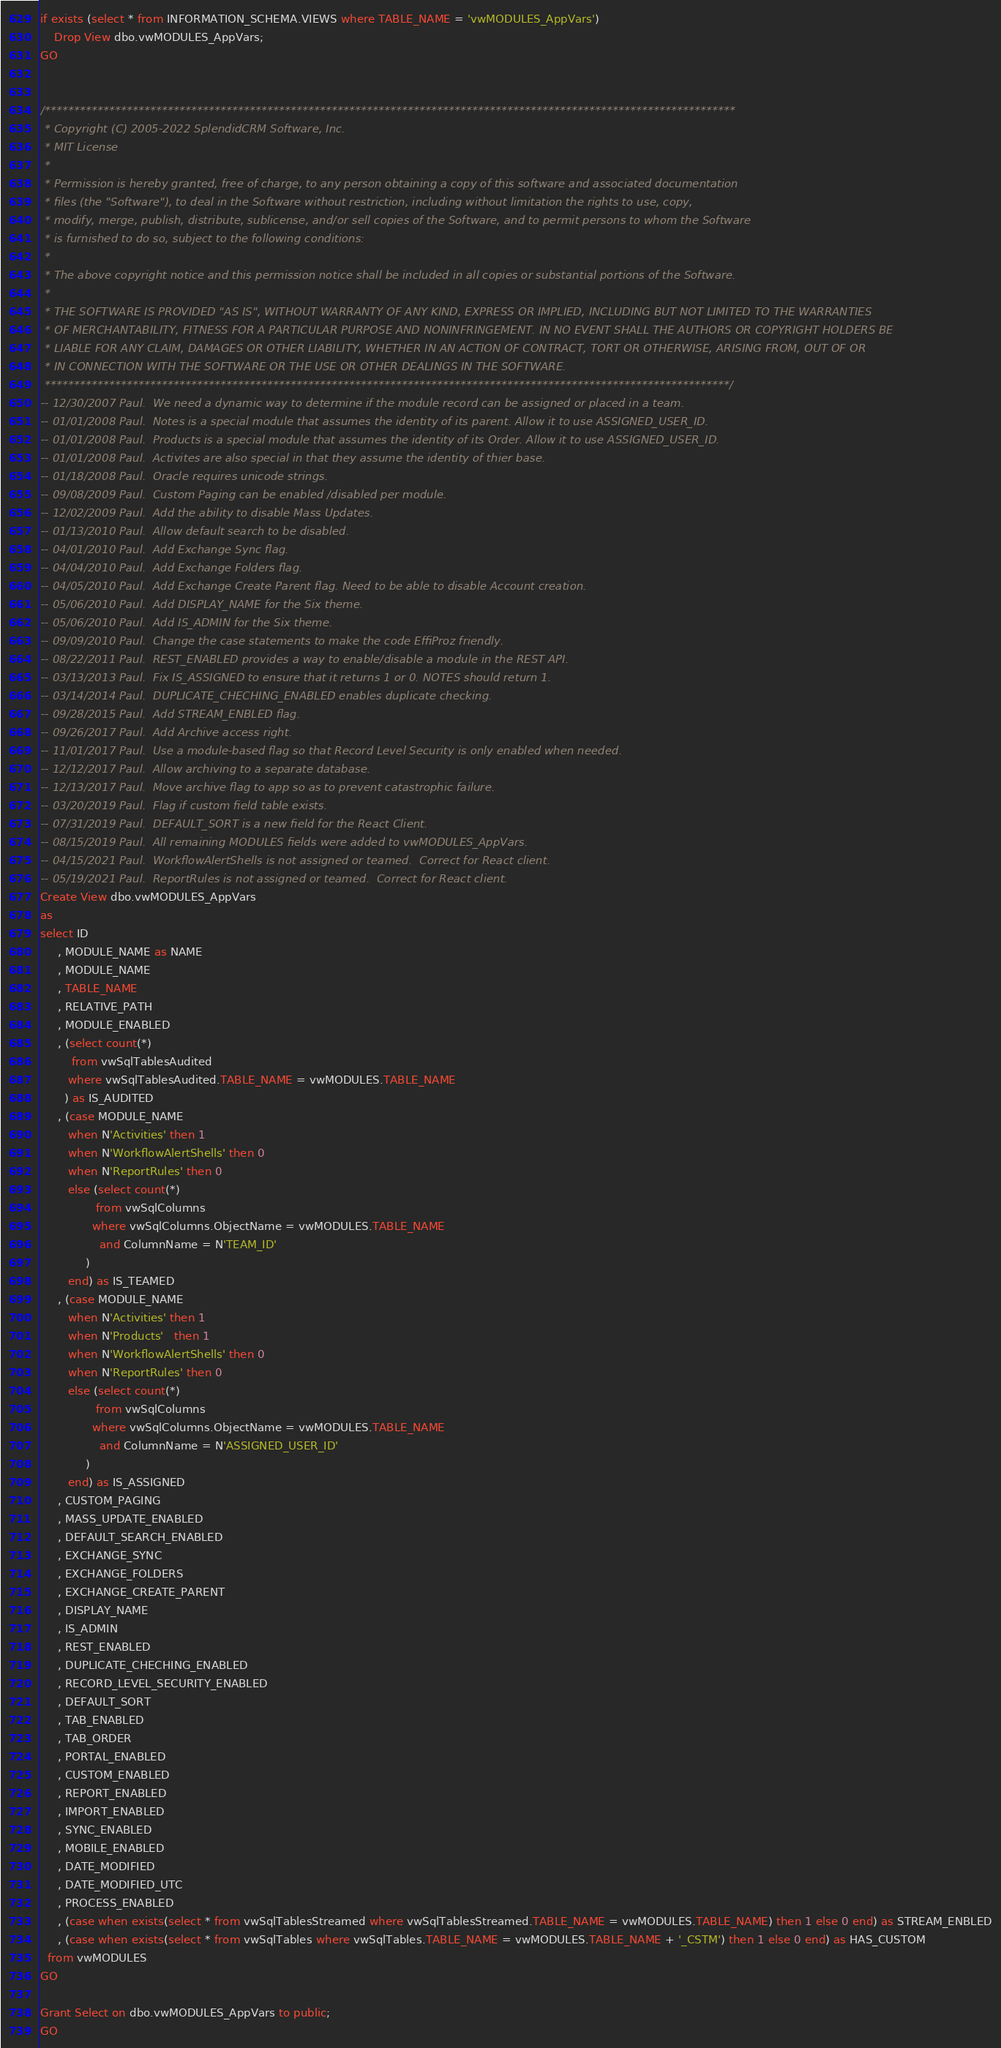<code> <loc_0><loc_0><loc_500><loc_500><_SQL_>if exists (select * from INFORMATION_SCHEMA.VIEWS where TABLE_NAME = 'vwMODULES_AppVars')
	Drop View dbo.vwMODULES_AppVars;
GO


/**********************************************************************************************************************
 * Copyright (C) 2005-2022 SplendidCRM Software, Inc. 
 * MIT License
 * 
 * Permission is hereby granted, free of charge, to any person obtaining a copy of this software and associated documentation 
 * files (the "Software"), to deal in the Software without restriction, including without limitation the rights to use, copy, 
 * modify, merge, publish, distribute, sublicense, and/or sell copies of the Software, and to permit persons to whom the Software 
 * is furnished to do so, subject to the following conditions:
 * 
 * The above copyright notice and this permission notice shall be included in all copies or substantial portions of the Software.
 * 
 * THE SOFTWARE IS PROVIDED "AS IS", WITHOUT WARRANTY OF ANY KIND, EXPRESS OR IMPLIED, INCLUDING BUT NOT LIMITED TO THE WARRANTIES 
 * OF MERCHANTABILITY, FITNESS FOR A PARTICULAR PURPOSE AND NONINFRINGEMENT. IN NO EVENT SHALL THE AUTHORS OR COPYRIGHT HOLDERS BE 
 * LIABLE FOR ANY CLAIM, DAMAGES OR OTHER LIABILITY, WHETHER IN AN ACTION OF CONTRACT, TORT OR OTHERWISE, ARISING FROM, OUT OF OR 
 * IN CONNECTION WITH THE SOFTWARE OR THE USE OR OTHER DEALINGS IN THE SOFTWARE.
 *********************************************************************************************************************/
-- 12/30/2007 Paul.  We need a dynamic way to determine if the module record can be assigned or placed in a team. 
-- 01/01/2008 Paul.  Notes is a special module that assumes the identity of its parent. Allow it to use ASSIGNED_USER_ID. 
-- 01/01/2008 Paul.  Products is a special module that assumes the identity of its Order. Allow it to use ASSIGNED_USER_ID. 
-- 01/01/2008 Paul.  Activites are also special in that they assume the identity of thier base. 
-- 01/18/2008 Paul.  Oracle requires unicode strings. 
-- 09/08/2009 Paul.  Custom Paging can be enabled /disabled per module. 
-- 12/02/2009 Paul.  Add the ability to disable Mass Updates. 
-- 01/13/2010 Paul.  Allow default search to be disabled. 
-- 04/01/2010 Paul.  Add Exchange Sync flag. 
-- 04/04/2010 Paul.  Add Exchange Folders flag. 
-- 04/05/2010 Paul.  Add Exchange Create Parent flag. Need to be able to disable Account creation. 
-- 05/06/2010 Paul.  Add DISPLAY_NAME for the Six theme. 
-- 05/06/2010 Paul.  Add IS_ADMIN for the Six theme. 
-- 09/09/2010 Paul.  Change the case statements to make the code EffiProz friendly. 
-- 08/22/2011 Paul.  REST_ENABLED provides a way to enable/disable a module in the REST API. 
-- 03/13/2013 Paul.  Fix IS_ASSIGNED to ensure that it returns 1 or 0. NOTES should return 1. 
-- 03/14/2014 Paul.  DUPLICATE_CHECHING_ENABLED enables duplicate checking. 
-- 09/28/2015 Paul.  Add STREAM_ENBLED flag. 
-- 09/26/2017 Paul.  Add Archive access right. 
-- 11/01/2017 Paul.  Use a module-based flag so that Record Level Security is only enabled when needed. 
-- 12/12/2017 Paul.  Allow archiving to a separate database. 
-- 12/13/2017 Paul.  Move archive flag to app so as to prevent catastrophic failure. 
-- 03/20/2019 Paul.  Flag if custom field table exists. 
-- 07/31/2019 Paul.  DEFAULT_SORT is a new field for the React Client. 
-- 08/15/2019 Paul.  All remaining MODULES fields were added to vwMODULES_AppVars. 
-- 04/15/2021 Paul.  WorkflowAlertShells is not assigned or teamed.  Correct for React client. 
-- 05/19/2021 Paul.  ReportRules is not assigned or teamed.  Correct for React client. 
Create View dbo.vwMODULES_AppVars
as
select ID
     , MODULE_NAME as NAME
     , MODULE_NAME
     , TABLE_NAME
     , RELATIVE_PATH
     , MODULE_ENABLED
     , (select count(*)
         from vwSqlTablesAudited
        where vwSqlTablesAudited.TABLE_NAME = vwMODULES.TABLE_NAME
       ) as IS_AUDITED
     , (case MODULE_NAME 
        when N'Activities' then 1
        when N'WorkflowAlertShells' then 0
        when N'ReportRules' then 0
        else (select count(*)
                from vwSqlColumns
               where vwSqlColumns.ObjectName = vwMODULES.TABLE_NAME
                 and ColumnName = N'TEAM_ID'
             )
        end) as IS_TEAMED
     , (case MODULE_NAME 
        when N'Activities' then 1
        when N'Products'   then 1
        when N'WorkflowAlertShells' then 0
        when N'ReportRules' then 0
        else (select count(*)
                from vwSqlColumns
               where vwSqlColumns.ObjectName = vwMODULES.TABLE_NAME
                 and ColumnName = N'ASSIGNED_USER_ID'
             )
        end) as IS_ASSIGNED
     , CUSTOM_PAGING
     , MASS_UPDATE_ENABLED
     , DEFAULT_SEARCH_ENABLED
     , EXCHANGE_SYNC
     , EXCHANGE_FOLDERS
     , EXCHANGE_CREATE_PARENT
     , DISPLAY_NAME
     , IS_ADMIN
     , REST_ENABLED
     , DUPLICATE_CHECHING_ENABLED
     , RECORD_LEVEL_SECURITY_ENABLED
     , DEFAULT_SORT
     , TAB_ENABLED
     , TAB_ORDER
     , PORTAL_ENABLED
     , CUSTOM_ENABLED
     , REPORT_ENABLED
     , IMPORT_ENABLED
     , SYNC_ENABLED
     , MOBILE_ENABLED
     , DATE_MODIFIED
     , DATE_MODIFIED_UTC
     , PROCESS_ENABLED
     , (case when exists(select * from vwSqlTablesStreamed where vwSqlTablesStreamed.TABLE_NAME = vwMODULES.TABLE_NAME) then 1 else 0 end) as STREAM_ENBLED
     , (case when exists(select * from vwSqlTables where vwSqlTables.TABLE_NAME = vwMODULES.TABLE_NAME + '_CSTM') then 1 else 0 end) as HAS_CUSTOM
  from vwMODULES
GO

Grant Select on dbo.vwMODULES_AppVars to public;
GO


</code> 